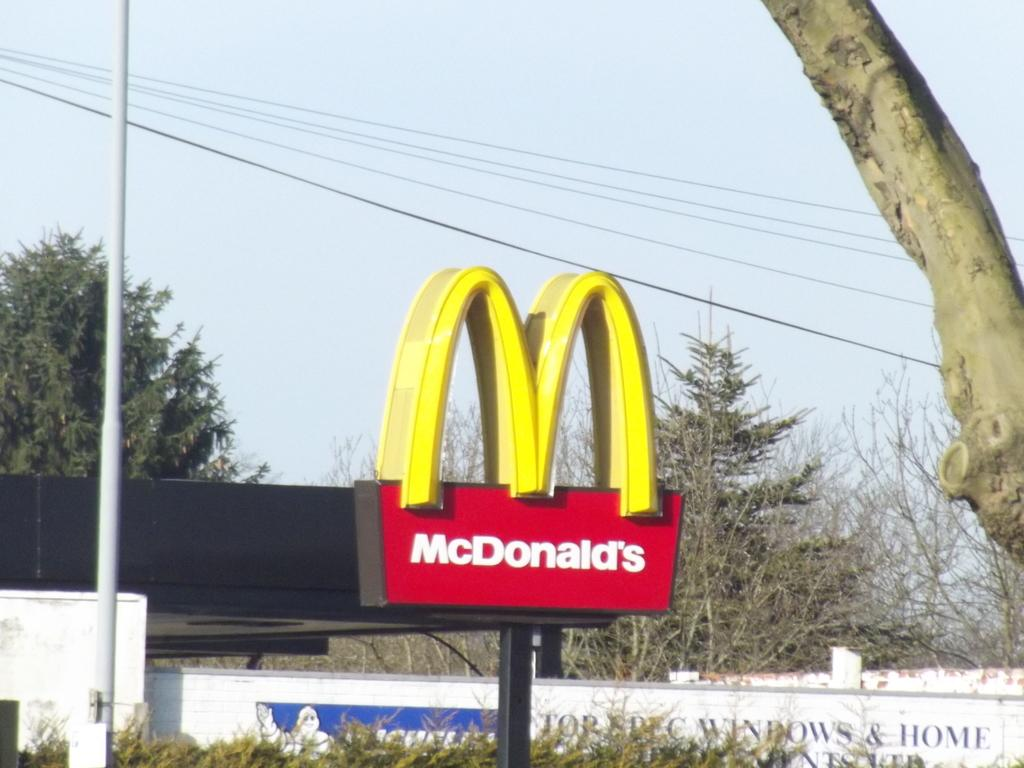What object in the image contains a name or title? There is a name plate in the image. What symbol or design is present in the image? There is a logo in the image. What type of vegetation can be seen in the image? There are plants and trees in the image. What is the condition of the sky in the image? The sky is clear in the image. What trick does the brother perform in the image? There is no brother or trick present in the image. 